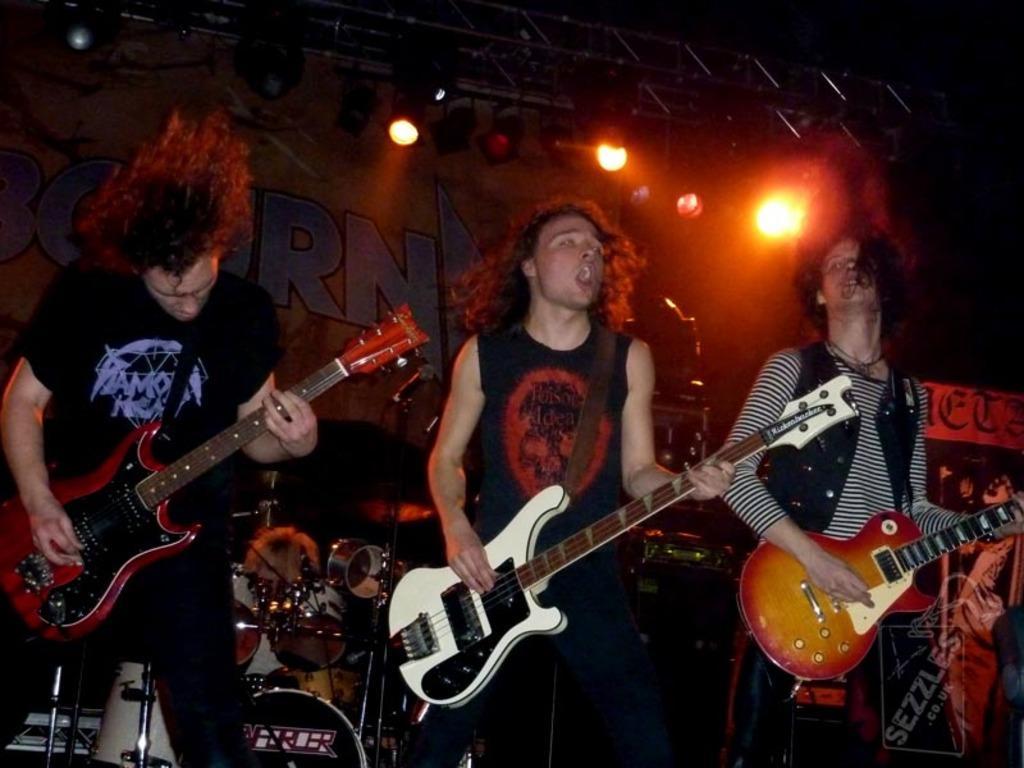Please provide a concise description of this image. This looks like a stage performance. There are three people standing and playing guitar. These are the drums. At background I can see a poster. These are the show lights hanging at the rooftop. At the right side I can see the banner. 